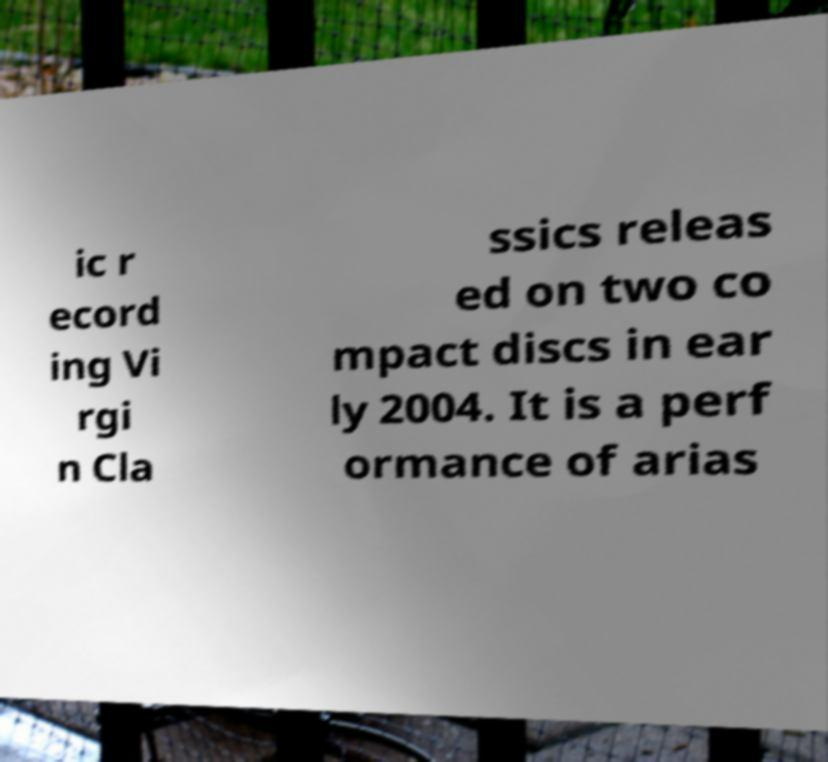Can you read and provide the text displayed in the image?This photo seems to have some interesting text. Can you extract and type it out for me? ic r ecord ing Vi rgi n Cla ssics releas ed on two co mpact discs in ear ly 2004. It is a perf ormance of arias 